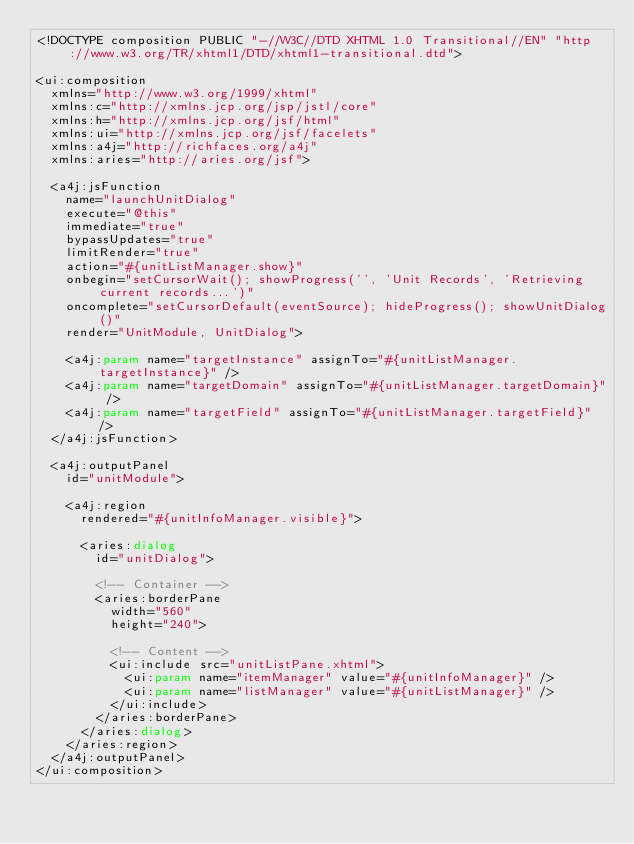Convert code to text. <code><loc_0><loc_0><loc_500><loc_500><_HTML_><!DOCTYPE composition PUBLIC "-//W3C//DTD XHTML 1.0 Transitional//EN" "http://www.w3.org/TR/xhtml1/DTD/xhtml1-transitional.dtd">

<ui:composition
	xmlns="http://www.w3.org/1999/xhtml"
	xmlns:c="http://xmlns.jcp.org/jsp/jstl/core"
	xmlns:h="http://xmlns.jcp.org/jsf/html"
	xmlns:ui="http://xmlns.jcp.org/jsf/facelets"
	xmlns:a4j="http://richfaces.org/a4j"
	xmlns:aries="http://aries.org/jsf">
	
	<a4j:jsFunction
	 	name="launchUnitDialog"
		execute="@this"
		immediate="true"
		bypassUpdates="true"
		limitRender="true"
		action="#{unitListManager.show}"
		onbegin="setCursorWait(); showProgress('', 'Unit Records', 'Retrieving current records...')"
		oncomplete="setCursorDefault(eventSource); hideProgress(); showUnitDialog()"
		render="UnitModule, UnitDialog">
		
		<a4j:param name="targetInstance" assignTo="#{unitListManager.targetInstance}" />
		<a4j:param name="targetDomain" assignTo="#{unitListManager.targetDomain}" />
		<a4j:param name="targetField" assignTo="#{unitListManager.targetField}" />
	</a4j:jsFunction>
	
	<a4j:outputPanel
		id="unitModule">
		
		<a4j:region
			rendered="#{unitInfoManager.visible}">
			
			<aries:dialog
				id="unitDialog">
				
				<!-- Container -->
				<aries:borderPane
					width="560"
					height="240">
					
					<!-- Content -->
					<ui:include src="unitListPane.xhtml">
						<ui:param name="itemManager" value="#{unitInfoManager}" />
						<ui:param name="listManager" value="#{unitListManager}" />
					</ui:include>
				</aries:borderPane>
			</aries:dialog>
		</aries:region>
	</a4j:outputPanel>
</ui:composition>
</code> 